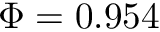Convert formula to latex. <formula><loc_0><loc_0><loc_500><loc_500>\Phi = 0 . 9 5 4</formula> 